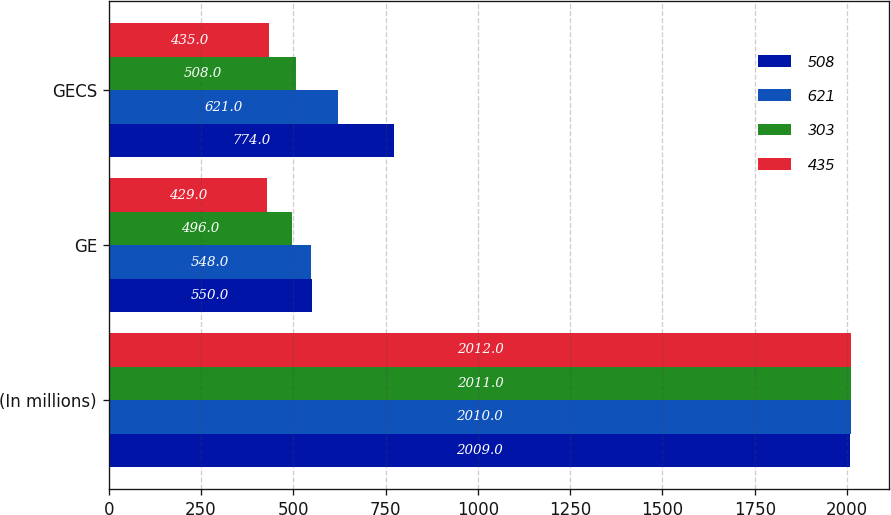Convert chart to OTSL. <chart><loc_0><loc_0><loc_500><loc_500><stacked_bar_chart><ecel><fcel>(In millions)<fcel>GE<fcel>GECS<nl><fcel>508<fcel>2009<fcel>550<fcel>774<nl><fcel>621<fcel>2010<fcel>548<fcel>621<nl><fcel>303<fcel>2011<fcel>496<fcel>508<nl><fcel>435<fcel>2012<fcel>429<fcel>435<nl></chart> 